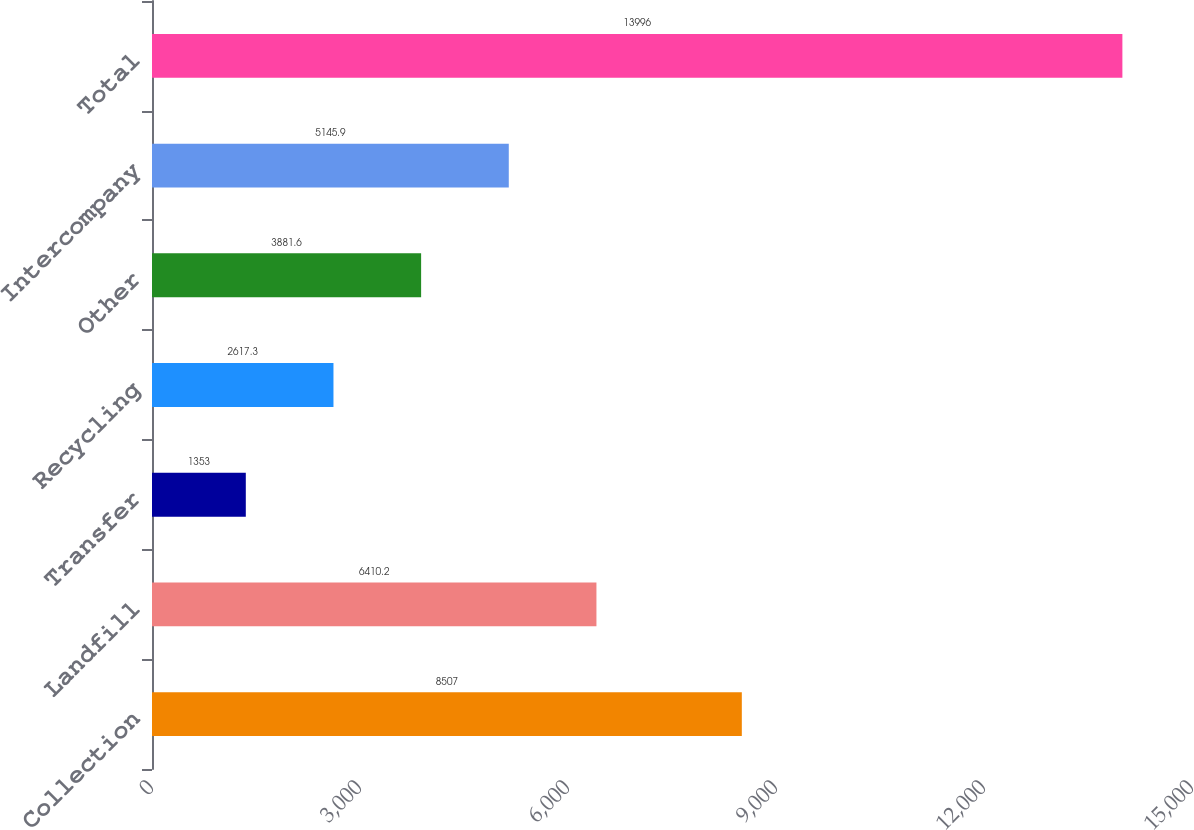Convert chart to OTSL. <chart><loc_0><loc_0><loc_500><loc_500><bar_chart><fcel>Collection<fcel>Landfill<fcel>Transfer<fcel>Recycling<fcel>Other<fcel>Intercompany<fcel>Total<nl><fcel>8507<fcel>6410.2<fcel>1353<fcel>2617.3<fcel>3881.6<fcel>5145.9<fcel>13996<nl></chart> 